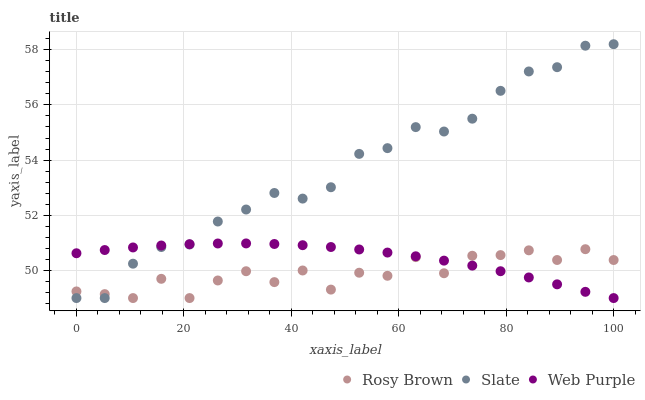Does Rosy Brown have the minimum area under the curve?
Answer yes or no. Yes. Does Slate have the maximum area under the curve?
Answer yes or no. Yes. Does Web Purple have the minimum area under the curve?
Answer yes or no. No. Does Web Purple have the maximum area under the curve?
Answer yes or no. No. Is Web Purple the smoothest?
Answer yes or no. Yes. Is Rosy Brown the roughest?
Answer yes or no. Yes. Is Rosy Brown the smoothest?
Answer yes or no. No. Is Web Purple the roughest?
Answer yes or no. No. Does Slate have the lowest value?
Answer yes or no. Yes. Does Slate have the highest value?
Answer yes or no. Yes. Does Web Purple have the highest value?
Answer yes or no. No. Does Slate intersect Web Purple?
Answer yes or no. Yes. Is Slate less than Web Purple?
Answer yes or no. No. Is Slate greater than Web Purple?
Answer yes or no. No. 